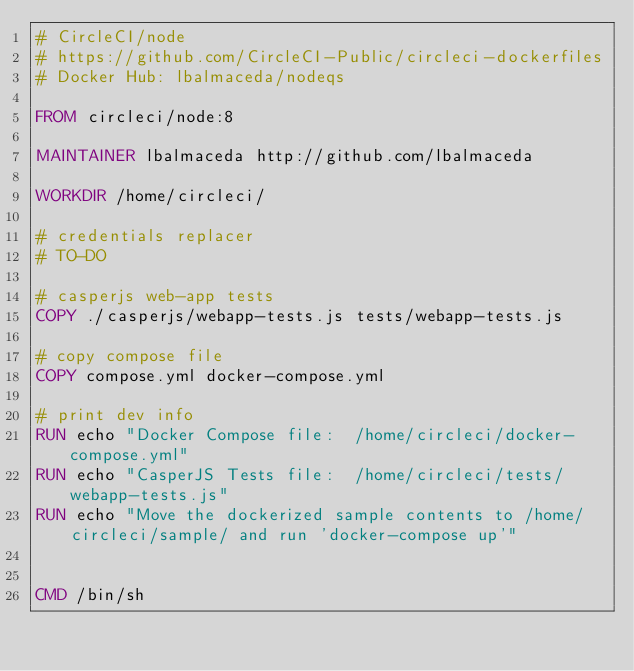Convert code to text. <code><loc_0><loc_0><loc_500><loc_500><_Dockerfile_># CircleCI/node
# https://github.com/CircleCI-Public/circleci-dockerfiles
# Docker Hub: lbalmaceda/nodeqs

FROM circleci/node:8

MAINTAINER lbalmaceda http://github.com/lbalmaceda

WORKDIR /home/circleci/

# credentials replacer
# TO-DO

# casperjs web-app tests
COPY ./casperjs/webapp-tests.js tests/webapp-tests.js

# copy compose file
COPY compose.yml docker-compose.yml

# print dev info
RUN echo "Docker Compose file:  /home/circleci/docker-compose.yml"
RUN echo "CasperJS Tests file:  /home/circleci/tests/webapp-tests.js"
RUN echo "Move the dockerized sample contents to /home/circleci/sample/ and run 'docker-compose up'"


CMD /bin/sh
</code> 